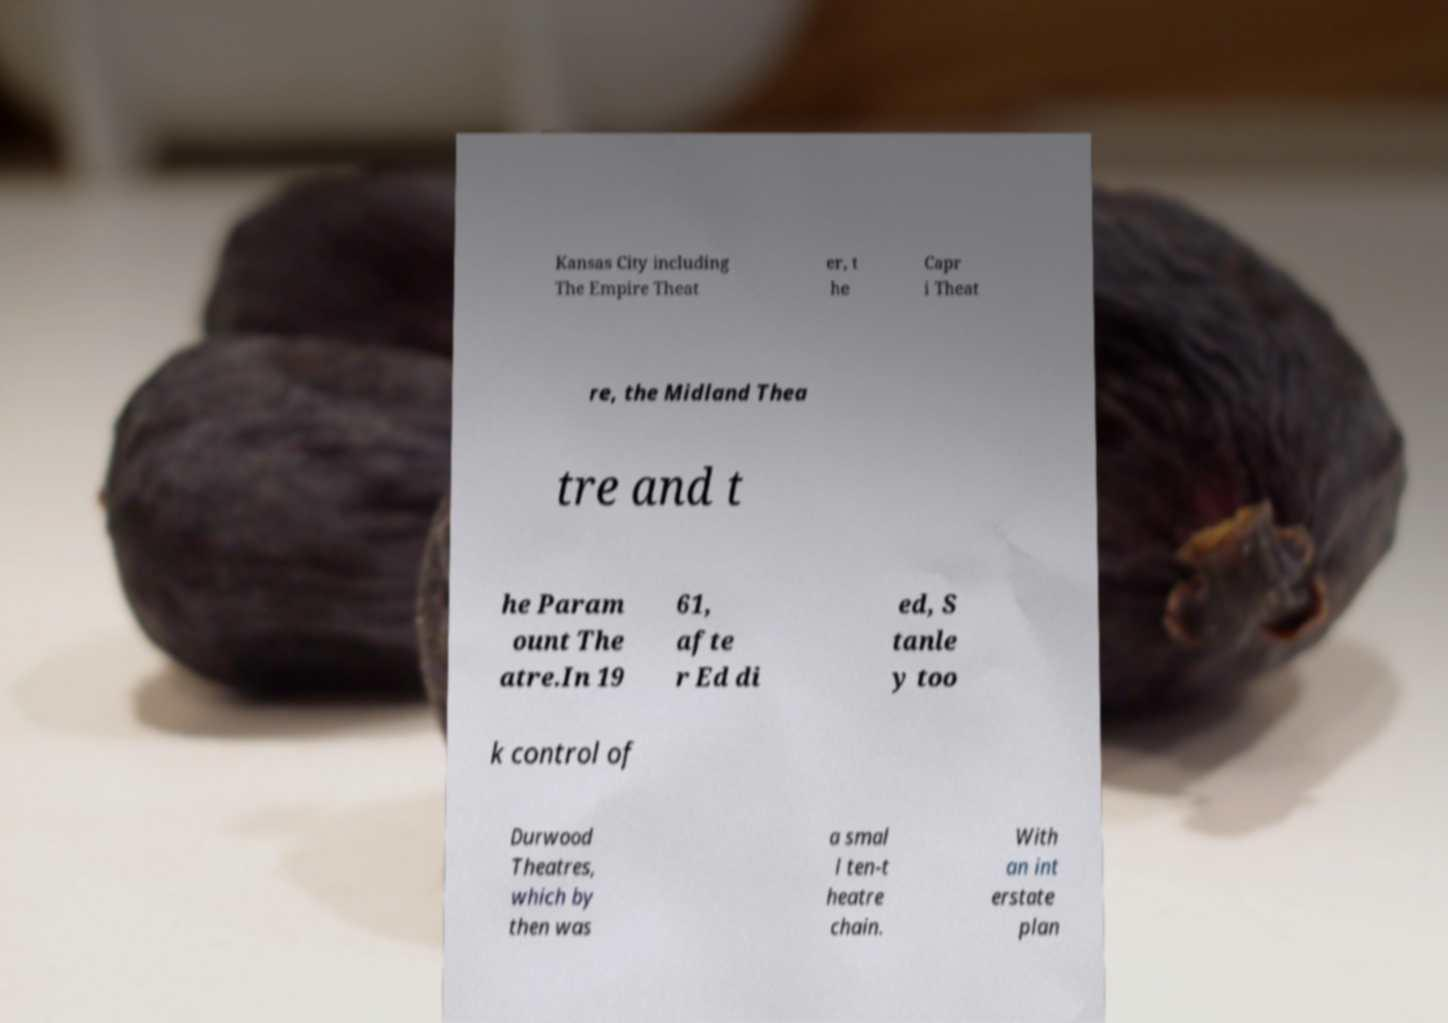What messages or text are displayed in this image? I need them in a readable, typed format. Kansas City including The Empire Theat er, t he Capr i Theat re, the Midland Thea tre and t he Param ount The atre.In 19 61, afte r Ed di ed, S tanle y too k control of Durwood Theatres, which by then was a smal l ten-t heatre chain. With an int erstate plan 